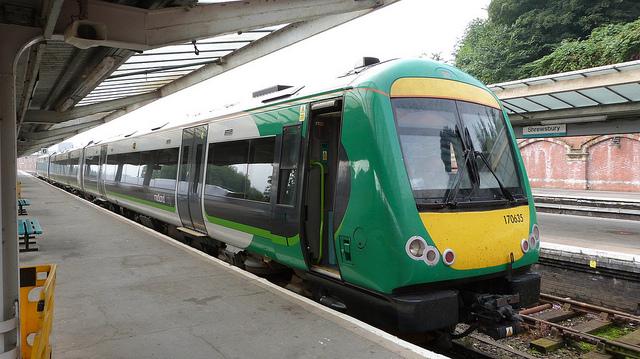Does this train go fast?
Keep it brief. Yes. Is this train station crowded?
Short answer required. No. How many doors are shown on the bus?
Give a very brief answer. 6. 